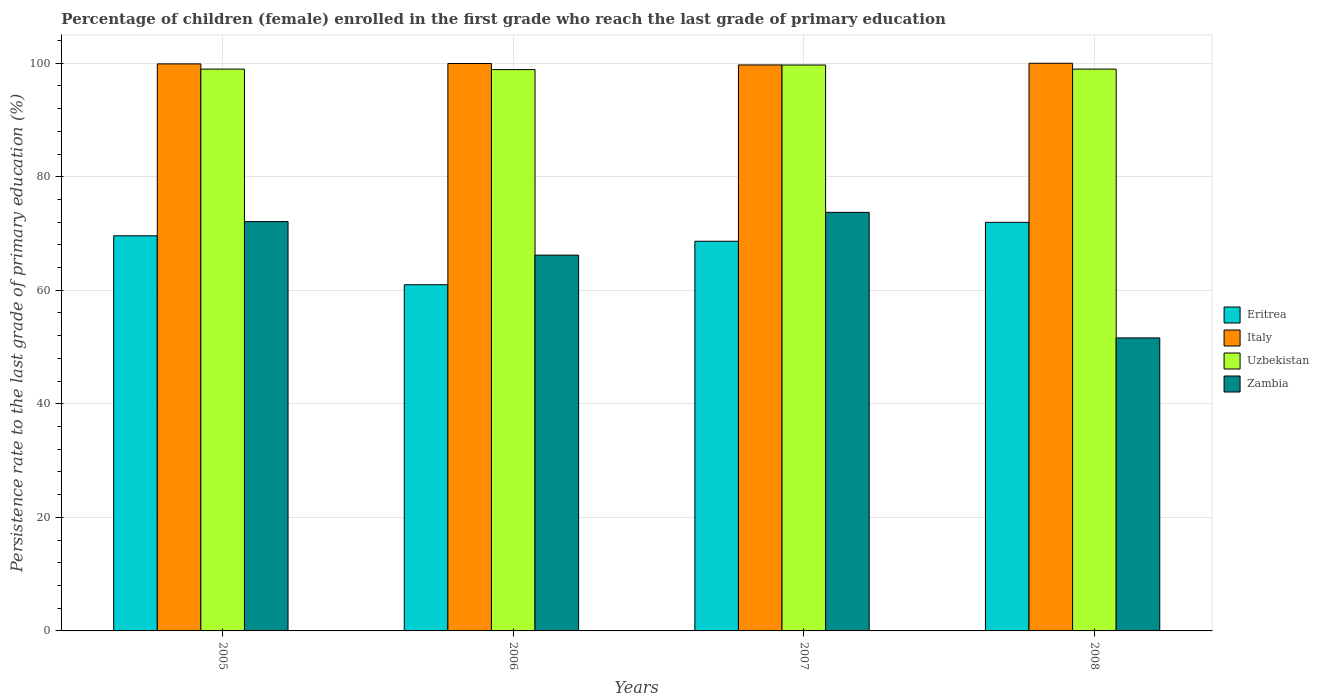How many groups of bars are there?
Provide a succinct answer. 4. Are the number of bars on each tick of the X-axis equal?
Provide a succinct answer. Yes. What is the label of the 2nd group of bars from the left?
Keep it short and to the point. 2006. What is the persistence rate of children in Italy in 2008?
Ensure brevity in your answer.  99.99. Across all years, what is the maximum persistence rate of children in Zambia?
Offer a terse response. 73.72. Across all years, what is the minimum persistence rate of children in Italy?
Keep it short and to the point. 99.69. In which year was the persistence rate of children in Zambia maximum?
Provide a succinct answer. 2007. In which year was the persistence rate of children in Zambia minimum?
Provide a short and direct response. 2008. What is the total persistence rate of children in Zambia in the graph?
Your response must be concise. 263.62. What is the difference between the persistence rate of children in Italy in 2006 and that in 2007?
Your answer should be very brief. 0.25. What is the difference between the persistence rate of children in Uzbekistan in 2007 and the persistence rate of children in Zambia in 2006?
Give a very brief answer. 33.49. What is the average persistence rate of children in Italy per year?
Your answer should be compact. 99.87. In the year 2005, what is the difference between the persistence rate of children in Italy and persistence rate of children in Uzbekistan?
Keep it short and to the point. 0.92. What is the ratio of the persistence rate of children in Eritrea in 2005 to that in 2007?
Give a very brief answer. 1.01. What is the difference between the highest and the second highest persistence rate of children in Italy?
Your answer should be very brief. 0.04. What is the difference between the highest and the lowest persistence rate of children in Uzbekistan?
Your response must be concise. 0.81. Is the sum of the persistence rate of children in Eritrea in 2007 and 2008 greater than the maximum persistence rate of children in Italy across all years?
Give a very brief answer. Yes. What does the 2nd bar from the left in 2005 represents?
Your response must be concise. Italy. What does the 3rd bar from the right in 2007 represents?
Offer a very short reply. Italy. How many bars are there?
Ensure brevity in your answer.  16. Are all the bars in the graph horizontal?
Ensure brevity in your answer.  No. What is the difference between two consecutive major ticks on the Y-axis?
Make the answer very short. 20. Does the graph contain grids?
Your response must be concise. Yes. Where does the legend appear in the graph?
Your answer should be very brief. Center right. How are the legend labels stacked?
Make the answer very short. Vertical. What is the title of the graph?
Your answer should be compact. Percentage of children (female) enrolled in the first grade who reach the last grade of primary education. What is the label or title of the X-axis?
Make the answer very short. Years. What is the label or title of the Y-axis?
Your response must be concise. Persistence rate to the last grade of primary education (%). What is the Persistence rate to the last grade of primary education (%) in Eritrea in 2005?
Provide a succinct answer. 69.59. What is the Persistence rate to the last grade of primary education (%) in Italy in 2005?
Your answer should be compact. 99.88. What is the Persistence rate to the last grade of primary education (%) of Uzbekistan in 2005?
Your answer should be very brief. 98.95. What is the Persistence rate to the last grade of primary education (%) of Zambia in 2005?
Give a very brief answer. 72.1. What is the Persistence rate to the last grade of primary education (%) of Eritrea in 2006?
Your response must be concise. 60.98. What is the Persistence rate to the last grade of primary education (%) in Italy in 2006?
Give a very brief answer. 99.95. What is the Persistence rate to the last grade of primary education (%) of Uzbekistan in 2006?
Offer a very short reply. 98.87. What is the Persistence rate to the last grade of primary education (%) in Zambia in 2006?
Provide a succinct answer. 66.19. What is the Persistence rate to the last grade of primary education (%) of Eritrea in 2007?
Offer a very short reply. 68.63. What is the Persistence rate to the last grade of primary education (%) of Italy in 2007?
Your response must be concise. 99.69. What is the Persistence rate to the last grade of primary education (%) in Uzbekistan in 2007?
Your answer should be compact. 99.68. What is the Persistence rate to the last grade of primary education (%) of Zambia in 2007?
Offer a terse response. 73.72. What is the Persistence rate to the last grade of primary education (%) of Eritrea in 2008?
Offer a very short reply. 71.96. What is the Persistence rate to the last grade of primary education (%) of Italy in 2008?
Ensure brevity in your answer.  99.99. What is the Persistence rate to the last grade of primary education (%) of Uzbekistan in 2008?
Your response must be concise. 98.96. What is the Persistence rate to the last grade of primary education (%) in Zambia in 2008?
Your answer should be very brief. 51.61. Across all years, what is the maximum Persistence rate to the last grade of primary education (%) of Eritrea?
Your answer should be compact. 71.96. Across all years, what is the maximum Persistence rate to the last grade of primary education (%) in Italy?
Provide a succinct answer. 99.99. Across all years, what is the maximum Persistence rate to the last grade of primary education (%) in Uzbekistan?
Give a very brief answer. 99.68. Across all years, what is the maximum Persistence rate to the last grade of primary education (%) in Zambia?
Offer a very short reply. 73.72. Across all years, what is the minimum Persistence rate to the last grade of primary education (%) in Eritrea?
Give a very brief answer. 60.98. Across all years, what is the minimum Persistence rate to the last grade of primary education (%) of Italy?
Provide a short and direct response. 99.69. Across all years, what is the minimum Persistence rate to the last grade of primary education (%) in Uzbekistan?
Your answer should be very brief. 98.87. Across all years, what is the minimum Persistence rate to the last grade of primary education (%) of Zambia?
Provide a succinct answer. 51.61. What is the total Persistence rate to the last grade of primary education (%) of Eritrea in the graph?
Give a very brief answer. 271.17. What is the total Persistence rate to the last grade of primary education (%) in Italy in the graph?
Give a very brief answer. 399.5. What is the total Persistence rate to the last grade of primary education (%) of Uzbekistan in the graph?
Provide a short and direct response. 396.46. What is the total Persistence rate to the last grade of primary education (%) of Zambia in the graph?
Provide a short and direct response. 263.62. What is the difference between the Persistence rate to the last grade of primary education (%) of Eritrea in 2005 and that in 2006?
Make the answer very short. 8.62. What is the difference between the Persistence rate to the last grade of primary education (%) in Italy in 2005 and that in 2006?
Give a very brief answer. -0.07. What is the difference between the Persistence rate to the last grade of primary education (%) in Uzbekistan in 2005 and that in 2006?
Keep it short and to the point. 0.08. What is the difference between the Persistence rate to the last grade of primary education (%) of Zambia in 2005 and that in 2006?
Your answer should be very brief. 5.91. What is the difference between the Persistence rate to the last grade of primary education (%) in Eritrea in 2005 and that in 2007?
Ensure brevity in your answer.  0.96. What is the difference between the Persistence rate to the last grade of primary education (%) of Italy in 2005 and that in 2007?
Offer a very short reply. 0.18. What is the difference between the Persistence rate to the last grade of primary education (%) in Uzbekistan in 2005 and that in 2007?
Make the answer very short. -0.73. What is the difference between the Persistence rate to the last grade of primary education (%) in Zambia in 2005 and that in 2007?
Provide a short and direct response. -1.62. What is the difference between the Persistence rate to the last grade of primary education (%) in Eritrea in 2005 and that in 2008?
Make the answer very short. -2.37. What is the difference between the Persistence rate to the last grade of primary education (%) of Italy in 2005 and that in 2008?
Provide a succinct answer. -0.11. What is the difference between the Persistence rate to the last grade of primary education (%) of Uzbekistan in 2005 and that in 2008?
Offer a terse response. -0. What is the difference between the Persistence rate to the last grade of primary education (%) of Zambia in 2005 and that in 2008?
Your answer should be compact. 20.49. What is the difference between the Persistence rate to the last grade of primary education (%) in Eritrea in 2006 and that in 2007?
Give a very brief answer. -7.66. What is the difference between the Persistence rate to the last grade of primary education (%) in Italy in 2006 and that in 2007?
Ensure brevity in your answer.  0.25. What is the difference between the Persistence rate to the last grade of primary education (%) in Uzbekistan in 2006 and that in 2007?
Your answer should be very brief. -0.81. What is the difference between the Persistence rate to the last grade of primary education (%) of Zambia in 2006 and that in 2007?
Ensure brevity in your answer.  -7.53. What is the difference between the Persistence rate to the last grade of primary education (%) of Eritrea in 2006 and that in 2008?
Your response must be concise. -10.99. What is the difference between the Persistence rate to the last grade of primary education (%) in Italy in 2006 and that in 2008?
Your response must be concise. -0.04. What is the difference between the Persistence rate to the last grade of primary education (%) in Uzbekistan in 2006 and that in 2008?
Provide a short and direct response. -0.08. What is the difference between the Persistence rate to the last grade of primary education (%) in Zambia in 2006 and that in 2008?
Offer a terse response. 14.58. What is the difference between the Persistence rate to the last grade of primary education (%) in Eritrea in 2007 and that in 2008?
Make the answer very short. -3.33. What is the difference between the Persistence rate to the last grade of primary education (%) of Italy in 2007 and that in 2008?
Ensure brevity in your answer.  -0.29. What is the difference between the Persistence rate to the last grade of primary education (%) of Uzbekistan in 2007 and that in 2008?
Provide a short and direct response. 0.72. What is the difference between the Persistence rate to the last grade of primary education (%) of Zambia in 2007 and that in 2008?
Make the answer very short. 22.12. What is the difference between the Persistence rate to the last grade of primary education (%) of Eritrea in 2005 and the Persistence rate to the last grade of primary education (%) of Italy in 2006?
Offer a terse response. -30.35. What is the difference between the Persistence rate to the last grade of primary education (%) of Eritrea in 2005 and the Persistence rate to the last grade of primary education (%) of Uzbekistan in 2006?
Offer a terse response. -29.28. What is the difference between the Persistence rate to the last grade of primary education (%) in Eritrea in 2005 and the Persistence rate to the last grade of primary education (%) in Zambia in 2006?
Make the answer very short. 3.4. What is the difference between the Persistence rate to the last grade of primary education (%) of Italy in 2005 and the Persistence rate to the last grade of primary education (%) of Uzbekistan in 2006?
Give a very brief answer. 1. What is the difference between the Persistence rate to the last grade of primary education (%) of Italy in 2005 and the Persistence rate to the last grade of primary education (%) of Zambia in 2006?
Your response must be concise. 33.69. What is the difference between the Persistence rate to the last grade of primary education (%) of Uzbekistan in 2005 and the Persistence rate to the last grade of primary education (%) of Zambia in 2006?
Ensure brevity in your answer.  32.76. What is the difference between the Persistence rate to the last grade of primary education (%) in Eritrea in 2005 and the Persistence rate to the last grade of primary education (%) in Italy in 2007?
Your answer should be very brief. -30.1. What is the difference between the Persistence rate to the last grade of primary education (%) in Eritrea in 2005 and the Persistence rate to the last grade of primary education (%) in Uzbekistan in 2007?
Your answer should be very brief. -30.09. What is the difference between the Persistence rate to the last grade of primary education (%) of Eritrea in 2005 and the Persistence rate to the last grade of primary education (%) of Zambia in 2007?
Offer a very short reply. -4.13. What is the difference between the Persistence rate to the last grade of primary education (%) of Italy in 2005 and the Persistence rate to the last grade of primary education (%) of Uzbekistan in 2007?
Make the answer very short. 0.2. What is the difference between the Persistence rate to the last grade of primary education (%) of Italy in 2005 and the Persistence rate to the last grade of primary education (%) of Zambia in 2007?
Provide a succinct answer. 26.15. What is the difference between the Persistence rate to the last grade of primary education (%) of Uzbekistan in 2005 and the Persistence rate to the last grade of primary education (%) of Zambia in 2007?
Your answer should be very brief. 25.23. What is the difference between the Persistence rate to the last grade of primary education (%) in Eritrea in 2005 and the Persistence rate to the last grade of primary education (%) in Italy in 2008?
Your answer should be compact. -30.39. What is the difference between the Persistence rate to the last grade of primary education (%) of Eritrea in 2005 and the Persistence rate to the last grade of primary education (%) of Uzbekistan in 2008?
Your answer should be very brief. -29.36. What is the difference between the Persistence rate to the last grade of primary education (%) of Eritrea in 2005 and the Persistence rate to the last grade of primary education (%) of Zambia in 2008?
Offer a terse response. 17.99. What is the difference between the Persistence rate to the last grade of primary education (%) of Italy in 2005 and the Persistence rate to the last grade of primary education (%) of Uzbekistan in 2008?
Give a very brief answer. 0.92. What is the difference between the Persistence rate to the last grade of primary education (%) in Italy in 2005 and the Persistence rate to the last grade of primary education (%) in Zambia in 2008?
Offer a terse response. 48.27. What is the difference between the Persistence rate to the last grade of primary education (%) of Uzbekistan in 2005 and the Persistence rate to the last grade of primary education (%) of Zambia in 2008?
Keep it short and to the point. 47.34. What is the difference between the Persistence rate to the last grade of primary education (%) in Eritrea in 2006 and the Persistence rate to the last grade of primary education (%) in Italy in 2007?
Your answer should be very brief. -38.71. What is the difference between the Persistence rate to the last grade of primary education (%) in Eritrea in 2006 and the Persistence rate to the last grade of primary education (%) in Uzbekistan in 2007?
Your answer should be very brief. -38.7. What is the difference between the Persistence rate to the last grade of primary education (%) in Eritrea in 2006 and the Persistence rate to the last grade of primary education (%) in Zambia in 2007?
Your answer should be very brief. -12.75. What is the difference between the Persistence rate to the last grade of primary education (%) of Italy in 2006 and the Persistence rate to the last grade of primary education (%) of Uzbekistan in 2007?
Provide a succinct answer. 0.27. What is the difference between the Persistence rate to the last grade of primary education (%) of Italy in 2006 and the Persistence rate to the last grade of primary education (%) of Zambia in 2007?
Keep it short and to the point. 26.22. What is the difference between the Persistence rate to the last grade of primary education (%) of Uzbekistan in 2006 and the Persistence rate to the last grade of primary education (%) of Zambia in 2007?
Offer a terse response. 25.15. What is the difference between the Persistence rate to the last grade of primary education (%) in Eritrea in 2006 and the Persistence rate to the last grade of primary education (%) in Italy in 2008?
Make the answer very short. -39.01. What is the difference between the Persistence rate to the last grade of primary education (%) of Eritrea in 2006 and the Persistence rate to the last grade of primary education (%) of Uzbekistan in 2008?
Your response must be concise. -37.98. What is the difference between the Persistence rate to the last grade of primary education (%) of Eritrea in 2006 and the Persistence rate to the last grade of primary education (%) of Zambia in 2008?
Your answer should be very brief. 9.37. What is the difference between the Persistence rate to the last grade of primary education (%) in Italy in 2006 and the Persistence rate to the last grade of primary education (%) in Zambia in 2008?
Offer a terse response. 48.34. What is the difference between the Persistence rate to the last grade of primary education (%) in Uzbekistan in 2006 and the Persistence rate to the last grade of primary education (%) in Zambia in 2008?
Keep it short and to the point. 47.26. What is the difference between the Persistence rate to the last grade of primary education (%) in Eritrea in 2007 and the Persistence rate to the last grade of primary education (%) in Italy in 2008?
Ensure brevity in your answer.  -31.35. What is the difference between the Persistence rate to the last grade of primary education (%) of Eritrea in 2007 and the Persistence rate to the last grade of primary education (%) of Uzbekistan in 2008?
Provide a short and direct response. -30.32. What is the difference between the Persistence rate to the last grade of primary education (%) of Eritrea in 2007 and the Persistence rate to the last grade of primary education (%) of Zambia in 2008?
Provide a short and direct response. 17.02. What is the difference between the Persistence rate to the last grade of primary education (%) of Italy in 2007 and the Persistence rate to the last grade of primary education (%) of Uzbekistan in 2008?
Offer a very short reply. 0.74. What is the difference between the Persistence rate to the last grade of primary education (%) in Italy in 2007 and the Persistence rate to the last grade of primary education (%) in Zambia in 2008?
Your answer should be very brief. 48.08. What is the difference between the Persistence rate to the last grade of primary education (%) in Uzbekistan in 2007 and the Persistence rate to the last grade of primary education (%) in Zambia in 2008?
Provide a succinct answer. 48.07. What is the average Persistence rate to the last grade of primary education (%) in Eritrea per year?
Make the answer very short. 67.79. What is the average Persistence rate to the last grade of primary education (%) of Italy per year?
Give a very brief answer. 99.87. What is the average Persistence rate to the last grade of primary education (%) in Uzbekistan per year?
Give a very brief answer. 99.11. What is the average Persistence rate to the last grade of primary education (%) in Zambia per year?
Keep it short and to the point. 65.91. In the year 2005, what is the difference between the Persistence rate to the last grade of primary education (%) in Eritrea and Persistence rate to the last grade of primary education (%) in Italy?
Make the answer very short. -30.28. In the year 2005, what is the difference between the Persistence rate to the last grade of primary education (%) of Eritrea and Persistence rate to the last grade of primary education (%) of Uzbekistan?
Make the answer very short. -29.36. In the year 2005, what is the difference between the Persistence rate to the last grade of primary education (%) of Eritrea and Persistence rate to the last grade of primary education (%) of Zambia?
Offer a terse response. -2.51. In the year 2005, what is the difference between the Persistence rate to the last grade of primary education (%) in Italy and Persistence rate to the last grade of primary education (%) in Uzbekistan?
Offer a terse response. 0.92. In the year 2005, what is the difference between the Persistence rate to the last grade of primary education (%) of Italy and Persistence rate to the last grade of primary education (%) of Zambia?
Give a very brief answer. 27.78. In the year 2005, what is the difference between the Persistence rate to the last grade of primary education (%) in Uzbekistan and Persistence rate to the last grade of primary education (%) in Zambia?
Ensure brevity in your answer.  26.85. In the year 2006, what is the difference between the Persistence rate to the last grade of primary education (%) in Eritrea and Persistence rate to the last grade of primary education (%) in Italy?
Make the answer very short. -38.97. In the year 2006, what is the difference between the Persistence rate to the last grade of primary education (%) in Eritrea and Persistence rate to the last grade of primary education (%) in Uzbekistan?
Keep it short and to the point. -37.89. In the year 2006, what is the difference between the Persistence rate to the last grade of primary education (%) in Eritrea and Persistence rate to the last grade of primary education (%) in Zambia?
Provide a succinct answer. -5.21. In the year 2006, what is the difference between the Persistence rate to the last grade of primary education (%) in Italy and Persistence rate to the last grade of primary education (%) in Uzbekistan?
Provide a succinct answer. 1.07. In the year 2006, what is the difference between the Persistence rate to the last grade of primary education (%) of Italy and Persistence rate to the last grade of primary education (%) of Zambia?
Give a very brief answer. 33.75. In the year 2006, what is the difference between the Persistence rate to the last grade of primary education (%) of Uzbekistan and Persistence rate to the last grade of primary education (%) of Zambia?
Provide a succinct answer. 32.68. In the year 2007, what is the difference between the Persistence rate to the last grade of primary education (%) of Eritrea and Persistence rate to the last grade of primary education (%) of Italy?
Your answer should be very brief. -31.06. In the year 2007, what is the difference between the Persistence rate to the last grade of primary education (%) of Eritrea and Persistence rate to the last grade of primary education (%) of Uzbekistan?
Your answer should be compact. -31.05. In the year 2007, what is the difference between the Persistence rate to the last grade of primary education (%) of Eritrea and Persistence rate to the last grade of primary education (%) of Zambia?
Ensure brevity in your answer.  -5.09. In the year 2007, what is the difference between the Persistence rate to the last grade of primary education (%) of Italy and Persistence rate to the last grade of primary education (%) of Uzbekistan?
Your response must be concise. 0.01. In the year 2007, what is the difference between the Persistence rate to the last grade of primary education (%) of Italy and Persistence rate to the last grade of primary education (%) of Zambia?
Keep it short and to the point. 25.97. In the year 2007, what is the difference between the Persistence rate to the last grade of primary education (%) of Uzbekistan and Persistence rate to the last grade of primary education (%) of Zambia?
Your response must be concise. 25.96. In the year 2008, what is the difference between the Persistence rate to the last grade of primary education (%) in Eritrea and Persistence rate to the last grade of primary education (%) in Italy?
Give a very brief answer. -28.02. In the year 2008, what is the difference between the Persistence rate to the last grade of primary education (%) in Eritrea and Persistence rate to the last grade of primary education (%) in Uzbekistan?
Make the answer very short. -26.99. In the year 2008, what is the difference between the Persistence rate to the last grade of primary education (%) in Eritrea and Persistence rate to the last grade of primary education (%) in Zambia?
Offer a terse response. 20.36. In the year 2008, what is the difference between the Persistence rate to the last grade of primary education (%) of Italy and Persistence rate to the last grade of primary education (%) of Uzbekistan?
Your answer should be very brief. 1.03. In the year 2008, what is the difference between the Persistence rate to the last grade of primary education (%) of Italy and Persistence rate to the last grade of primary education (%) of Zambia?
Provide a short and direct response. 48.38. In the year 2008, what is the difference between the Persistence rate to the last grade of primary education (%) in Uzbekistan and Persistence rate to the last grade of primary education (%) in Zambia?
Ensure brevity in your answer.  47.35. What is the ratio of the Persistence rate to the last grade of primary education (%) of Eritrea in 2005 to that in 2006?
Your answer should be very brief. 1.14. What is the ratio of the Persistence rate to the last grade of primary education (%) in Uzbekistan in 2005 to that in 2006?
Keep it short and to the point. 1. What is the ratio of the Persistence rate to the last grade of primary education (%) in Zambia in 2005 to that in 2006?
Provide a succinct answer. 1.09. What is the ratio of the Persistence rate to the last grade of primary education (%) of Italy in 2005 to that in 2007?
Provide a succinct answer. 1. What is the ratio of the Persistence rate to the last grade of primary education (%) in Eritrea in 2005 to that in 2008?
Provide a succinct answer. 0.97. What is the ratio of the Persistence rate to the last grade of primary education (%) in Italy in 2005 to that in 2008?
Keep it short and to the point. 1. What is the ratio of the Persistence rate to the last grade of primary education (%) of Uzbekistan in 2005 to that in 2008?
Your response must be concise. 1. What is the ratio of the Persistence rate to the last grade of primary education (%) in Zambia in 2005 to that in 2008?
Your answer should be very brief. 1.4. What is the ratio of the Persistence rate to the last grade of primary education (%) in Eritrea in 2006 to that in 2007?
Your answer should be compact. 0.89. What is the ratio of the Persistence rate to the last grade of primary education (%) in Zambia in 2006 to that in 2007?
Ensure brevity in your answer.  0.9. What is the ratio of the Persistence rate to the last grade of primary education (%) in Eritrea in 2006 to that in 2008?
Offer a terse response. 0.85. What is the ratio of the Persistence rate to the last grade of primary education (%) in Italy in 2006 to that in 2008?
Give a very brief answer. 1. What is the ratio of the Persistence rate to the last grade of primary education (%) in Uzbekistan in 2006 to that in 2008?
Your answer should be very brief. 1. What is the ratio of the Persistence rate to the last grade of primary education (%) in Zambia in 2006 to that in 2008?
Keep it short and to the point. 1.28. What is the ratio of the Persistence rate to the last grade of primary education (%) in Eritrea in 2007 to that in 2008?
Give a very brief answer. 0.95. What is the ratio of the Persistence rate to the last grade of primary education (%) in Italy in 2007 to that in 2008?
Make the answer very short. 1. What is the ratio of the Persistence rate to the last grade of primary education (%) in Uzbekistan in 2007 to that in 2008?
Your answer should be very brief. 1.01. What is the ratio of the Persistence rate to the last grade of primary education (%) of Zambia in 2007 to that in 2008?
Keep it short and to the point. 1.43. What is the difference between the highest and the second highest Persistence rate to the last grade of primary education (%) of Eritrea?
Your response must be concise. 2.37. What is the difference between the highest and the second highest Persistence rate to the last grade of primary education (%) in Italy?
Offer a very short reply. 0.04. What is the difference between the highest and the second highest Persistence rate to the last grade of primary education (%) in Uzbekistan?
Your response must be concise. 0.72. What is the difference between the highest and the second highest Persistence rate to the last grade of primary education (%) of Zambia?
Your answer should be very brief. 1.62. What is the difference between the highest and the lowest Persistence rate to the last grade of primary education (%) of Eritrea?
Provide a succinct answer. 10.99. What is the difference between the highest and the lowest Persistence rate to the last grade of primary education (%) of Italy?
Provide a short and direct response. 0.29. What is the difference between the highest and the lowest Persistence rate to the last grade of primary education (%) of Uzbekistan?
Your response must be concise. 0.81. What is the difference between the highest and the lowest Persistence rate to the last grade of primary education (%) of Zambia?
Your answer should be very brief. 22.12. 